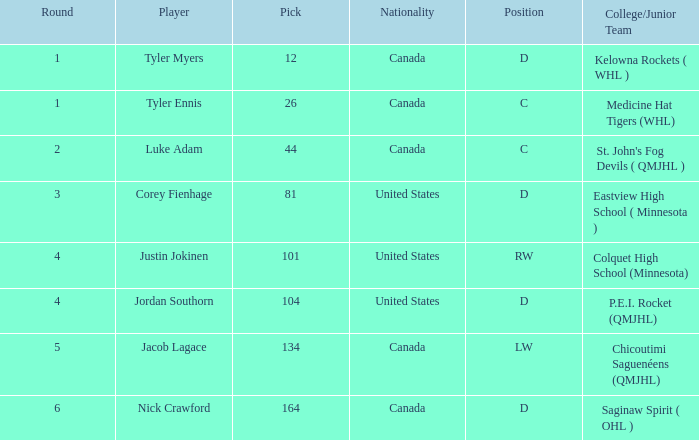I'm looking to parse the entire table for insights. Could you assist me with that? {'header': ['Round', 'Player', 'Pick', 'Nationality', 'Position', 'College/Junior Team'], 'rows': [['1', 'Tyler Myers', '12', 'Canada', 'D', 'Kelowna Rockets ( WHL )'], ['1', 'Tyler Ennis', '26', 'Canada', 'C', 'Medicine Hat Tigers (WHL)'], ['2', 'Luke Adam', '44', 'Canada', 'C', "St. John's Fog Devils ( QMJHL )"], ['3', 'Corey Fienhage', '81', 'United States', 'D', 'Eastview High School ( Minnesota )'], ['4', 'Justin Jokinen', '101', 'United States', 'RW', 'Colquet High School (Minnesota)'], ['4', 'Jordan Southorn', '104', 'United States', 'D', 'P.E.I. Rocket (QMJHL)'], ['5', 'Jacob Lagace', '134', 'Canada', 'LW', 'Chicoutimi Saguenéens (QMJHL)'], ['6', 'Nick Crawford', '164', 'Canada', 'D', 'Saginaw Spirit ( OHL )']]} What is the nationality of player corey fienhage, who has a pick less than 104? United States. 